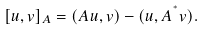<formula> <loc_0><loc_0><loc_500><loc_500>[ u , v ] _ { A } = ( A u , v ) - ( u , A ^ { ^ { * } } v ) .</formula> 